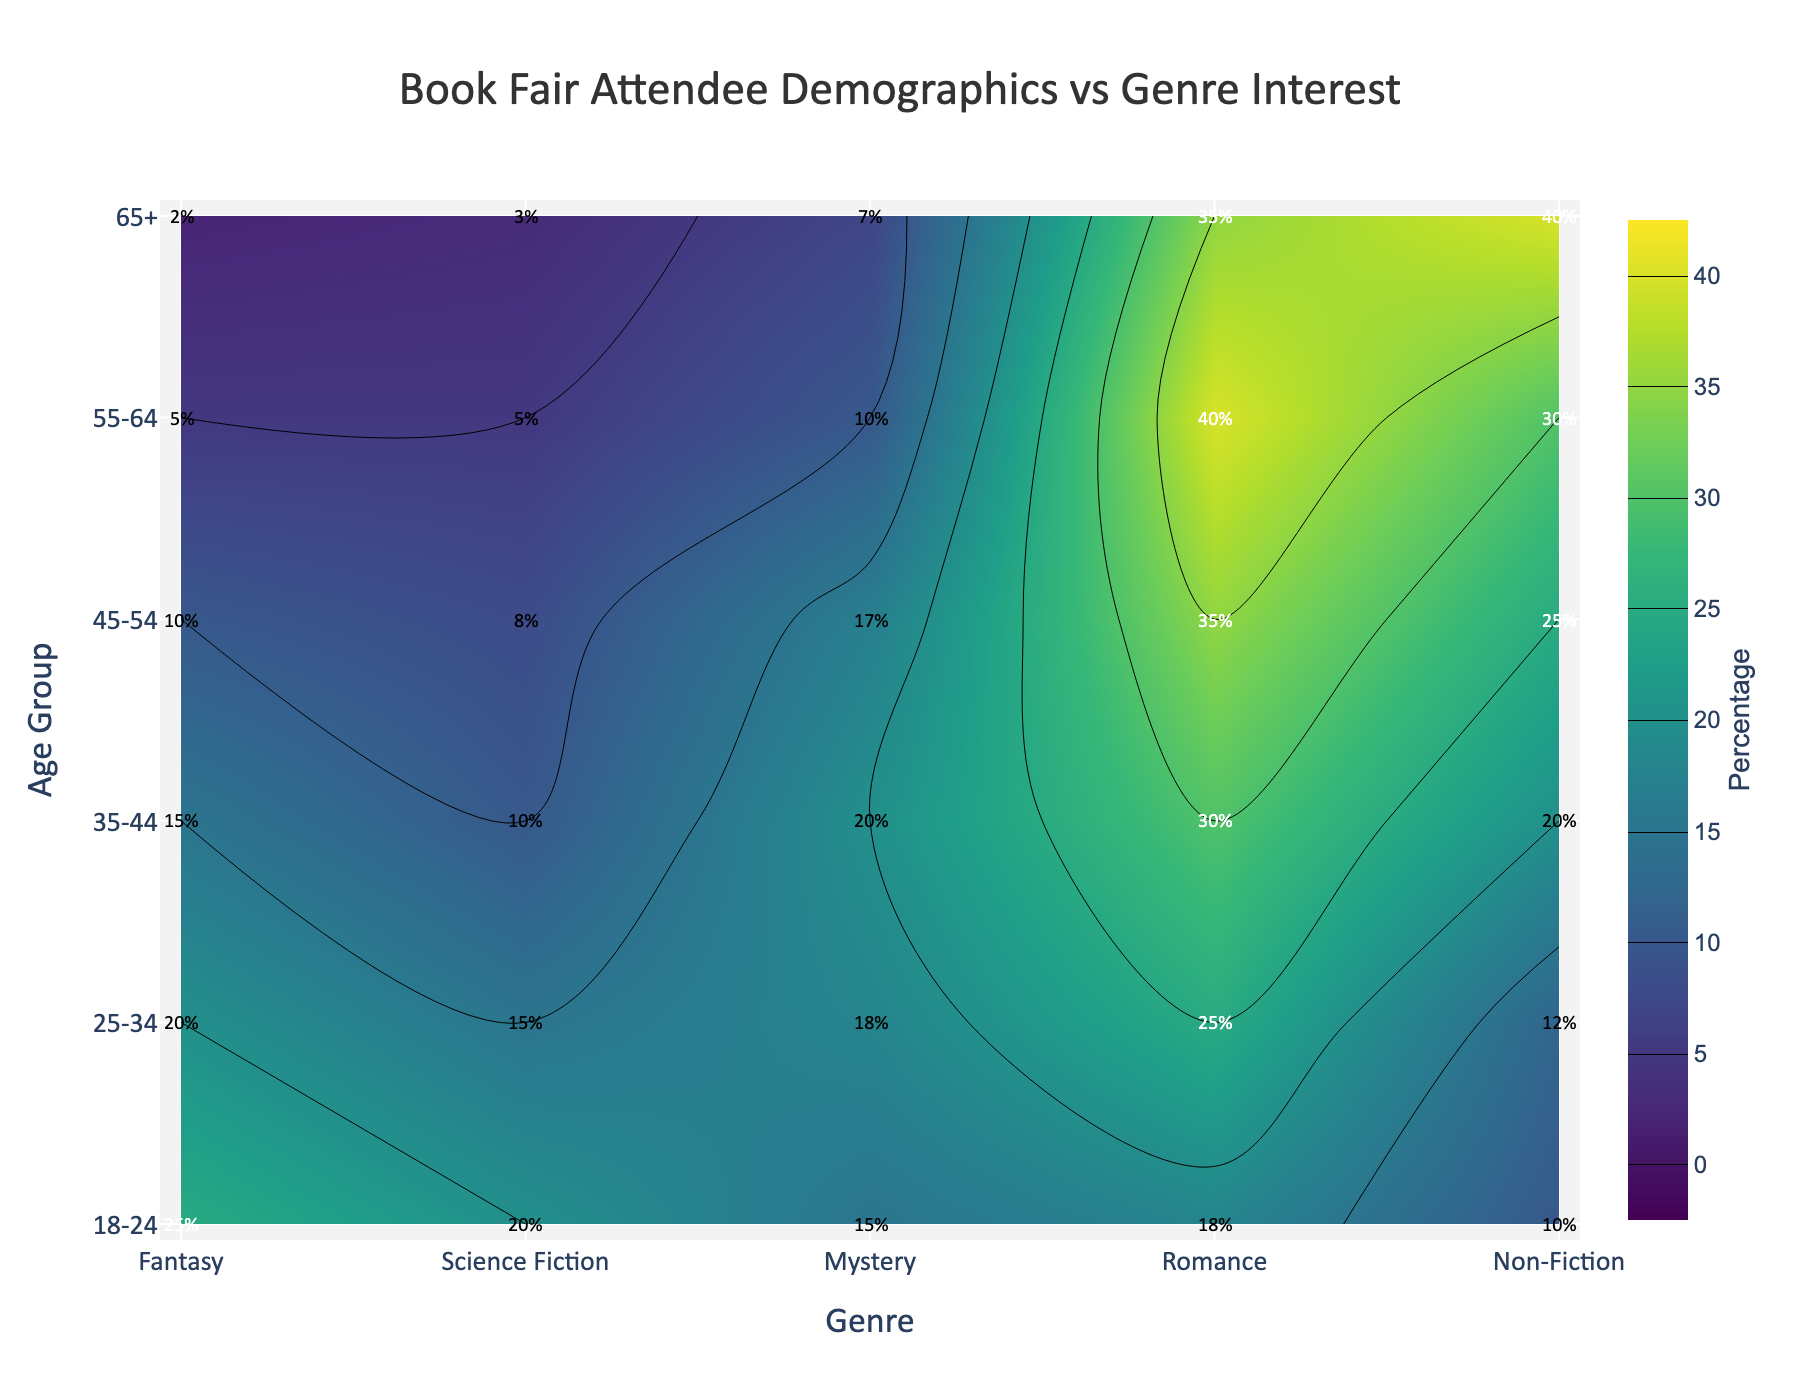What's the title of the plot? The title of the plot is displayed at the top center of the figure. It reads 'Book Fair Attendee Demographics vs Genre Interest'.
Answer: Book Fair Attendee Demographics vs Genre Interest Which age group shows the highest interest in Romance books? By examining the 'Romance' column in the contour plot, we see that '55-64' age group has the highest percentage, displayed as 40%.
Answer: 55-64 What percentage of attendees aged 25-34 are interested in Science Fiction? Locate the intersection of the '25-34' row and the 'Science Fiction' column. The percentage value shown is 15%.
Answer: 15% Compare the percentage of interest in Mystery books between the age groups 18-24 and 45-54. Which age group has a higher interest? In the 'Mystery' column, the percentage for '18-24' is 15%, and for '45-54' it is 17%. Therefore, 45-54 has a higher interest.
Answer: 45-54 What is the difference in percentage interest in Non-Fiction between age groups 35-44 and 55-64? The percentage for Non-Fiction in the '35-44' age group is 20%, and for '55-64' it is 30%. The difference is 30% - 20% = 10%.
Answer: 10% Which genre has the least interest among the 65+ age group? In the '65+' row, compare the percentage values across all genres. The least interest is in 'Fantasy' with a percentage of 2%.
Answer: Fantasy What is the average percentage interest in Romance books across all age groups? Sum the percentages for 'Romance' across all age groups (18 + 25 + 30 + 35 + 40 + 35 = 183). There are 6 age groups, hence the average is 183 / 6 = 30.5%.
Answer: 30.5% Identify the age group and genre with the highest value in the contour plot. By scanning all annotation percentages in the plot, the highest value is seen in 'Romance' for the '55-64' age group with 40%.
Answer: 55-64, Romance Which age group shows a consistent increase in interest for Non-Fiction as they get older? By observing the 'Non-Fiction' column from youngest to oldest, the percentages increase from 10 to 12 to 20 to 25 to 30 to 40.
Answer: All age groups show an increase What is the combined interest percentage in Fantasy and Science Fiction for the age group 35-44? Sum the percentages for 'Fantasy' and 'Science Fiction' for the '35-44' age group (15 + 10 = 25%).
Answer: 25% 